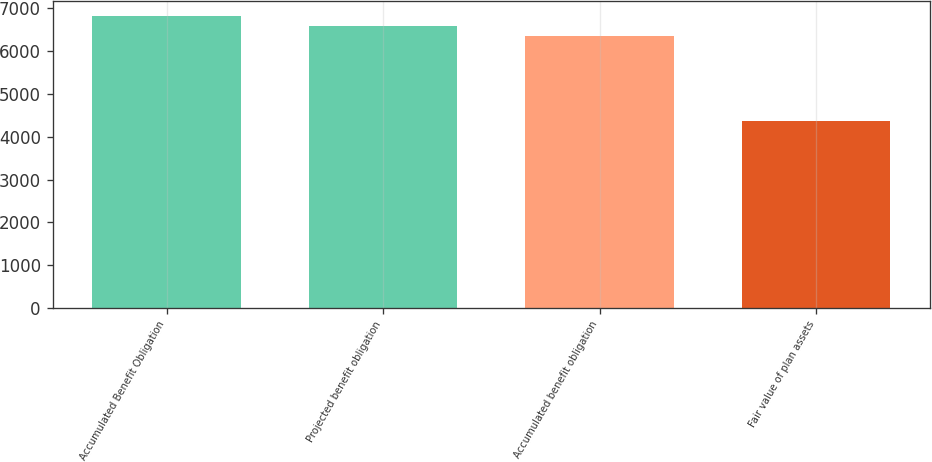Convert chart to OTSL. <chart><loc_0><loc_0><loc_500><loc_500><bar_chart><fcel>Accumulated Benefit Obligation<fcel>Projected benefit obligation<fcel>Accumulated benefit obligation<fcel>Fair value of plan assets<nl><fcel>6819<fcel>6585.5<fcel>6352<fcel>4360<nl></chart> 